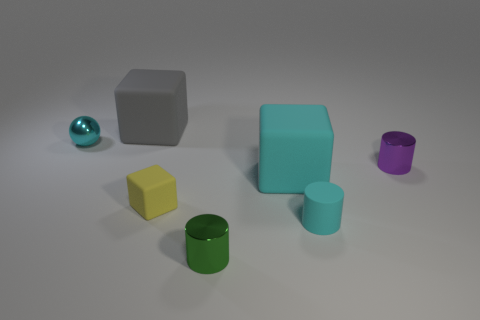Is the number of gray rubber cubes right of the large gray matte thing less than the number of tiny purple matte balls?
Your answer should be very brief. No. How many large cyan objects are there?
Your response must be concise. 1. There is a shiny object that is on the left side of the matte cube that is left of the yellow matte cube; what is its shape?
Your answer should be compact. Sphere. How many purple objects are on the left side of the rubber cylinder?
Give a very brief answer. 0. Is the small green object made of the same material as the tiny cylinder that is on the right side of the tiny cyan cylinder?
Your answer should be very brief. Yes. Are there any cyan balls of the same size as the purple cylinder?
Provide a short and direct response. Yes. Are there an equal number of tiny cyan shiny things on the left side of the tiny cyan metal object and small metallic spheres?
Offer a very short reply. No. What size is the purple thing?
Ensure brevity in your answer.  Small. There is a rubber object that is on the right side of the big cyan rubber cube; what number of cyan rubber objects are to the left of it?
Offer a terse response. 1. What is the shape of the matte thing that is left of the big cyan rubber thing and in front of the gray matte thing?
Keep it short and to the point. Cube. 